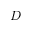Convert formula to latex. <formula><loc_0><loc_0><loc_500><loc_500>D</formula> 